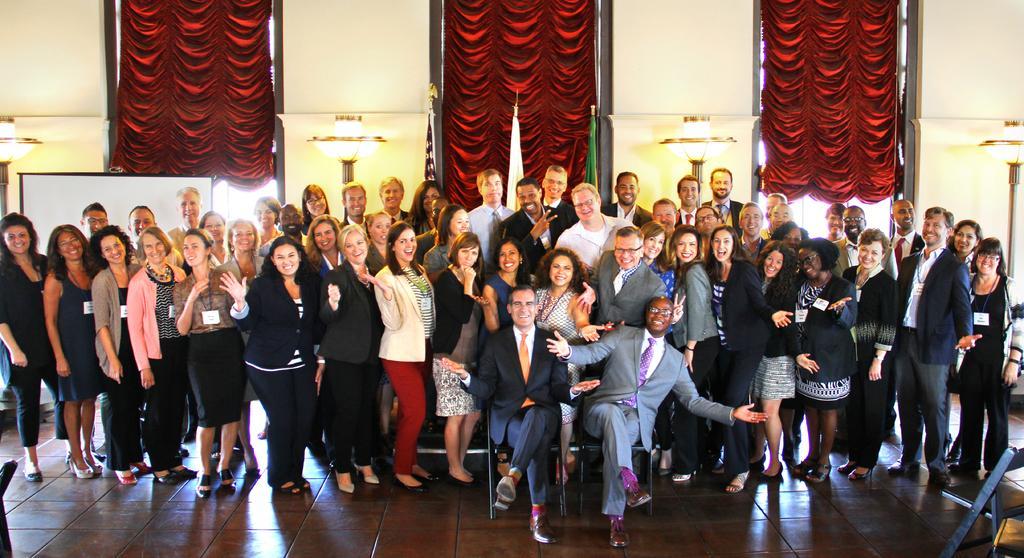Can you describe this image briefly? There are group of people those who are standing in the center of the image and there are two men those who are sitting on chairs and there are lamp poles, red color curtains, and flags in the background area, it seems to be, there is an object in the bottom right side of the image. 